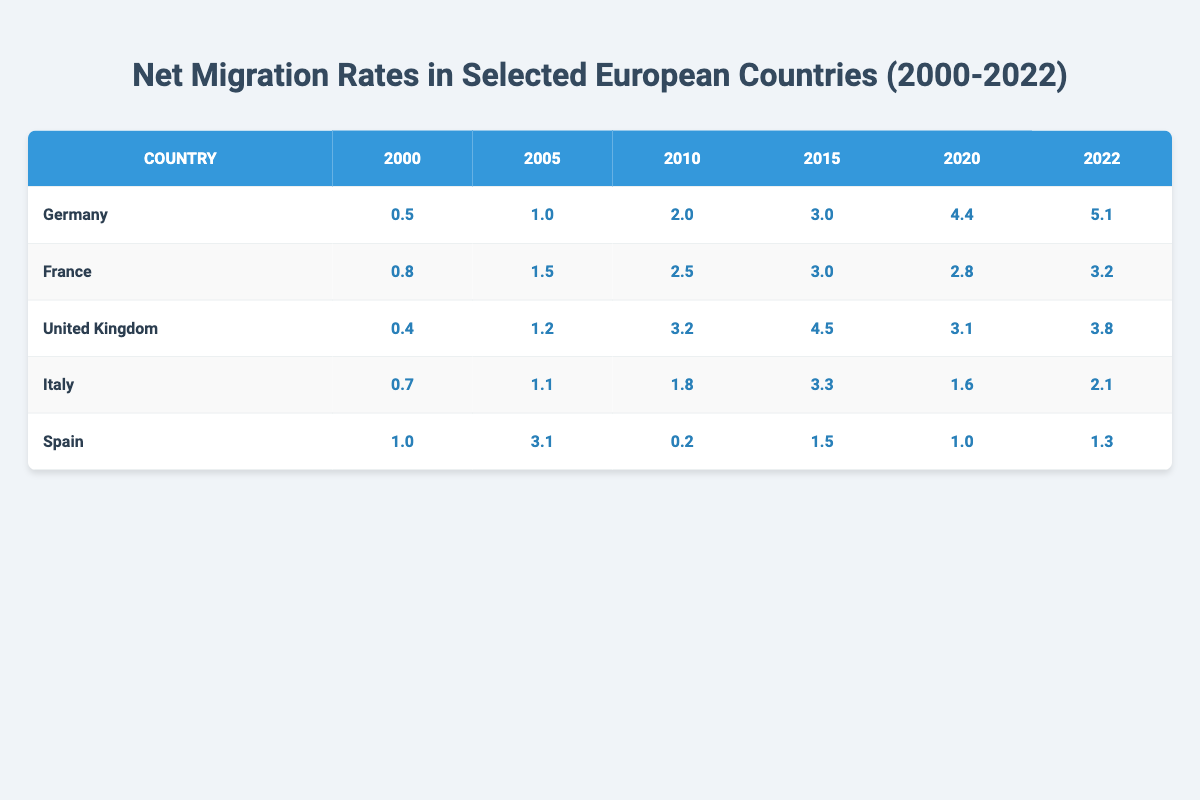What was the net migration rate for Germany in 2022? According to the table, the net migration rate for Germany in 2022 is located in the same row under the '2022' column, which shows a value of 5.1.
Answer: 5.1 Which country had the highest net migration rate in 2015? By comparing the '2015' column for all countries, the highest value is found in Germany, which is 3.0, while other countries have lower values.
Answer: Germany What was the average net migration rate for France from 2000 to 2022? The rates for France are: 0.8, 1.5, 2.5, 3.0, 2.8, and 3.2. To find the average, we sum these values (0.8 + 1.5 + 2.5 + 3.0 + 2.8 + 3.2 = 13.8) and then divide by the number of years (6), resulting in an average of 2.3.
Answer: 2.3 Did Italy's net migration rate increase in 2021 compared to previous years? By looking at the migration rates for Italy over the years, they are: 0.7 (2000), 1.1 (2005), 1.8 (2010), 3.3 (2015), 1.6 (2020), and 2.1 (2022). Notably, there is no data for 2021; thus, we cannot determine an increase for that specific year.
Answer: No What is the difference between the highest and lowest net migration rates for the United Kingdom from 2000 to 2022? The highest rate for the United Kingdom is 4.5 (in 2015) and the lowest is 0.4 (in 2000). To find the difference, we subtract the lowest from the highest (4.5 - 0.4 = 4.1).
Answer: 4.1 Which country experienced the most significant decline in net migration rate from 2010 to 2020? For the year 2010, Spain had a rate of 0.2, and by 2020, it was 1.0. Other countries display increases. By checking each country's values from those years, we see that Spain had a decline of 2.8 (from 2.5 to 2.8) within that period.
Answer: Spain Is it true that France's migration rate was below 3 in 2020? Checking the value for France in the 2020 column, it is 2.8, which is indeed below 3, making the statement true.
Answer: Yes What was the trend of net migration rates in Germany from 2000 to 2022? The rates for Germany are observed to consistently increase from 0.5 in 2000 to 5.1 in 2022. This clear uptrend indicates a significant rise over those years.
Answer: Increase 